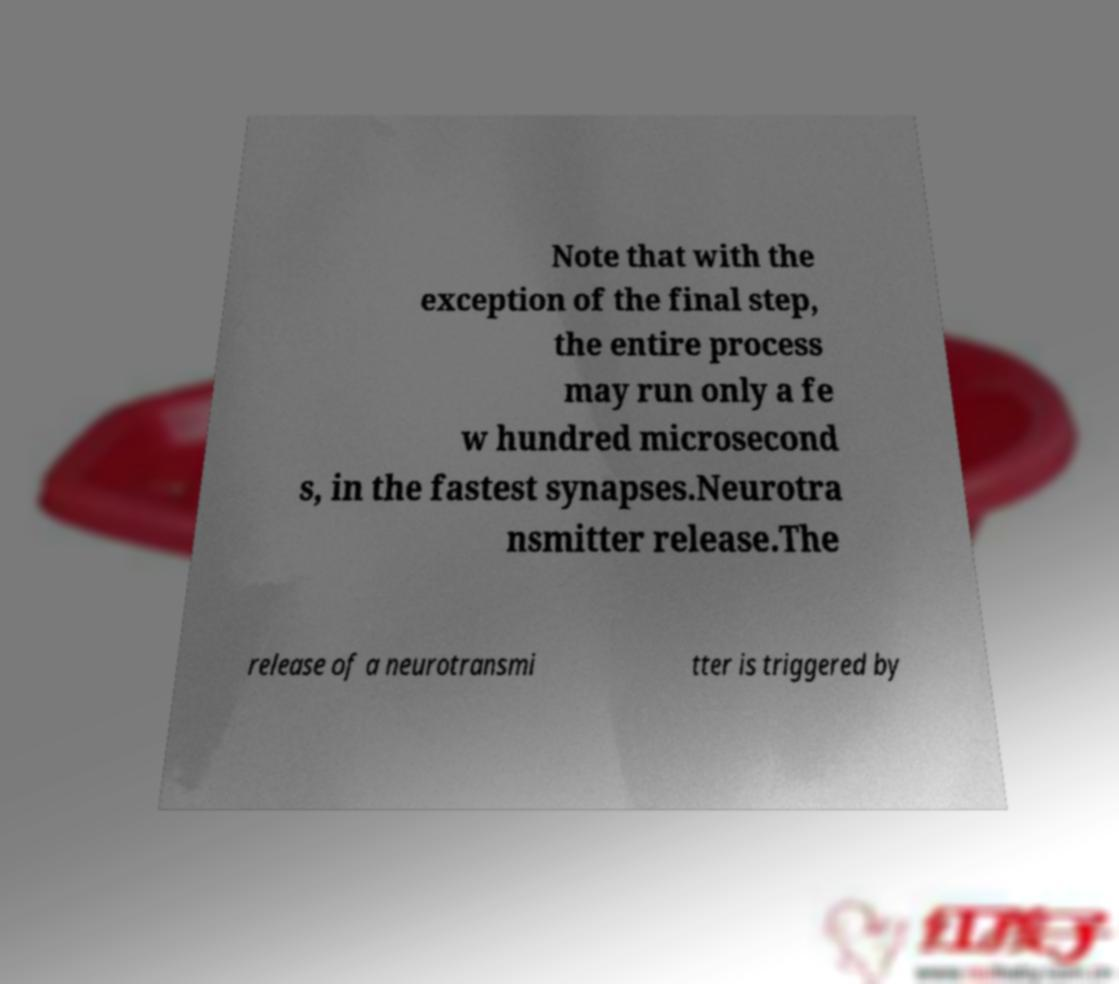Please read and relay the text visible in this image. What does it say? Note that with the exception of the final step, the entire process may run only a fe w hundred microsecond s, in the fastest synapses.Neurotra nsmitter release.The release of a neurotransmi tter is triggered by 